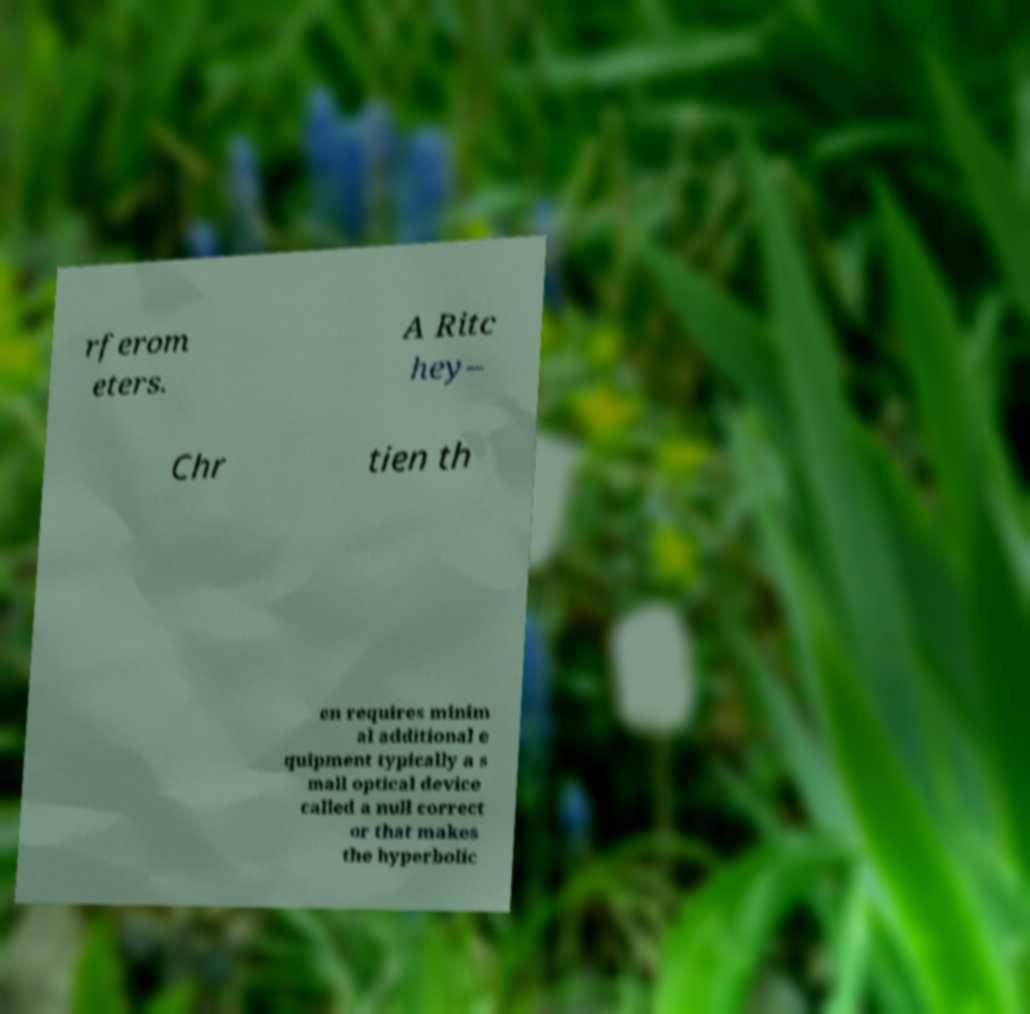Please identify and transcribe the text found in this image. rferom eters. A Ritc hey– Chr tien th en requires minim al additional e quipment typically a s mall optical device called a null correct or that makes the hyperbolic 